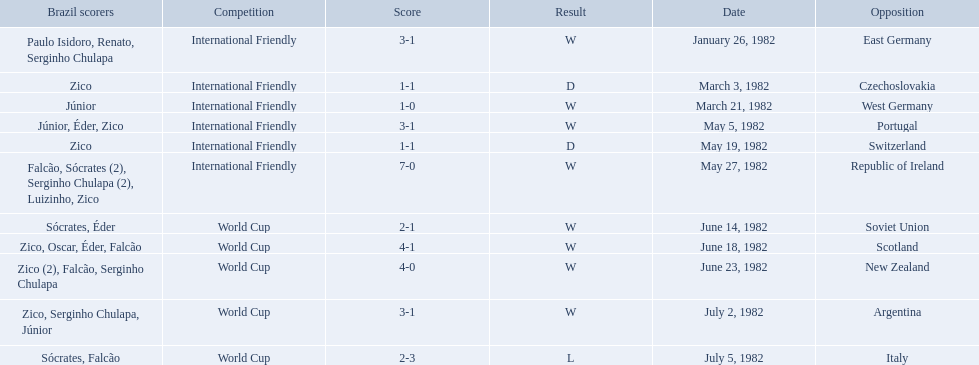What are all the dates of games in 1982 in brazilian football? January 26, 1982, March 3, 1982, March 21, 1982, May 5, 1982, May 19, 1982, May 27, 1982, June 14, 1982, June 18, 1982, June 23, 1982, July 2, 1982, July 5, 1982. Help me parse the entirety of this table. {'header': ['Brazil scorers', 'Competition', 'Score', 'Result', 'Date', 'Opposition'], 'rows': [['Paulo Isidoro, Renato, Serginho Chulapa', 'International Friendly', '3-1', 'W', 'January 26, 1982', 'East Germany'], ['Zico', 'International Friendly', '1-1', 'D', 'March 3, 1982', 'Czechoslovakia'], ['Júnior', 'International Friendly', '1-0', 'W', 'March 21, 1982', 'West Germany'], ['Júnior, Éder, Zico', 'International Friendly', '3-1', 'W', 'May 5, 1982', 'Portugal'], ['Zico', 'International Friendly', '1-1', 'D', 'May 19, 1982', 'Switzerland'], ['Falcão, Sócrates (2), Serginho Chulapa (2), Luizinho, Zico', 'International Friendly', '7-0', 'W', 'May 27, 1982', 'Republic of Ireland'], ['Sócrates, Éder', 'World Cup', '2-1', 'W', 'June 14, 1982', 'Soviet Union'], ['Zico, Oscar, Éder, Falcão', 'World Cup', '4-1', 'W', 'June 18, 1982', 'Scotland'], ['Zico (2), Falcão, Serginho Chulapa', 'World Cup', '4-0', 'W', 'June 23, 1982', 'New Zealand'], ['Zico, Serginho Chulapa, Júnior', 'World Cup', '3-1', 'W', 'July 2, 1982', 'Argentina'], ['Sócrates, Falcão', 'World Cup', '2-3', 'L', 'July 5, 1982', 'Italy']]} Which of these dates is at the top of the chart? January 26, 1982. 